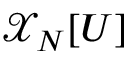Convert formula to latex. <formula><loc_0><loc_0><loc_500><loc_500>\mathcal { X } _ { N } [ U ]</formula> 